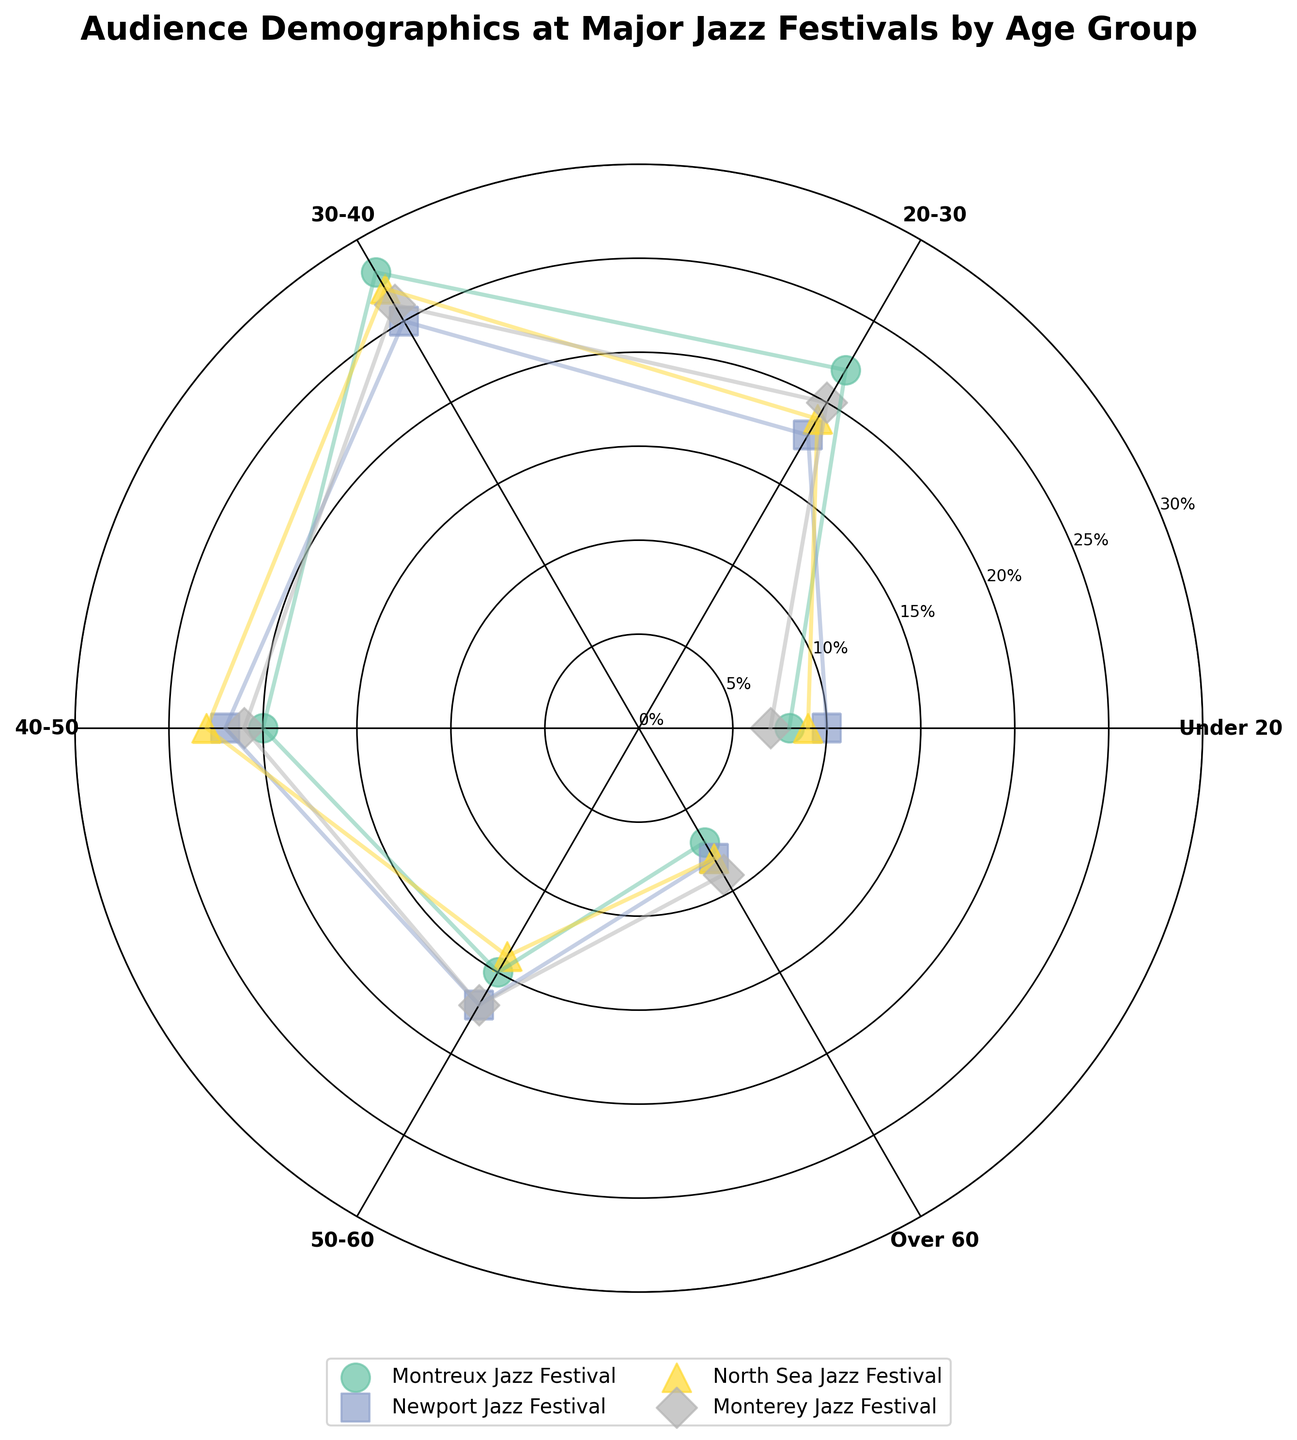What's the title of the figure? The title is typically at the top of the figure and provides a summary of what data is being visualized. In this case, it is written in bold and centered above the chart.
Answer: Audience Demographics at Major Jazz Festivals by Age Group Which age group has the highest percentage at the Newport Jazz Festival? Look at the radial values of the points labeled with "Newport Jazz Festival". Find the point with the highest value and note its corresponding age group on the angular axis.
Answer: 30-40 How many unique festivals are represented in the chart? Each festival is represented by unique markers and colors. Count the distinct legend entries to determine the number of festivals.
Answer: 4 Which festival has the lowest percentage for the 50-60 age group? Observe the radial values for the points corresponding to "50-60" around the chart. Identify the one with the smallest radial distance among different colors and markers.
Answer: Montreux Jazz Festival What is the percentage difference between the "20-30" age groups at the Montreux Jazz Festival and the Monterey Jazz Festival? Locate the points corresponding to "20-30" for Montreux and Monterey. Subtract the smaller percentage from the larger one.
Answer: 2% Which age group shows the least variation in audience percentages across all festivals? Compare the range of radial values for each age group across all festivals. Identify the smallest range (difference between maximum and minimum values).
Answer: Over 60 What is the average percentage of the "Under 20" audience across all festivals? Sum the percentages of the "Under 20" age group for each festival, then divide by the number of festivals.
Answer: 8.5% In which age group does the North Sea Jazz Festival have a higher percentage than the Montreux Jazz Festival? Compare the radial values of North Sea Jazz Festival and Montreux Jazz Festival for each age group and identify where North Sea's percentage is higher.
Answer: 40-50 What are the colors used to represent each festival in the chart? Identify the different colors used for the markers and lines corresponding to each festival from the legend.
Answer: Montreux Jazz Festival: one color, Newport Jazz Festival: another color, etc. (Specific colors will vary based on the 'Set2' colormap) Which age group has the highest audience percentage overall? Scan all age groups across all festivals and find the point with the maximum radial value. Note its corresponding age group.
Answer: 30-40 